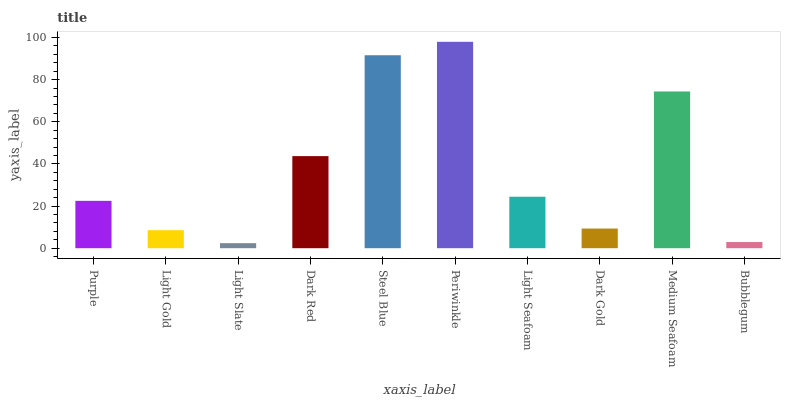Is Light Gold the minimum?
Answer yes or no. No. Is Light Gold the maximum?
Answer yes or no. No. Is Purple greater than Light Gold?
Answer yes or no. Yes. Is Light Gold less than Purple?
Answer yes or no. Yes. Is Light Gold greater than Purple?
Answer yes or no. No. Is Purple less than Light Gold?
Answer yes or no. No. Is Light Seafoam the high median?
Answer yes or no. Yes. Is Purple the low median?
Answer yes or no. Yes. Is Light Gold the high median?
Answer yes or no. No. Is Light Slate the low median?
Answer yes or no. No. 